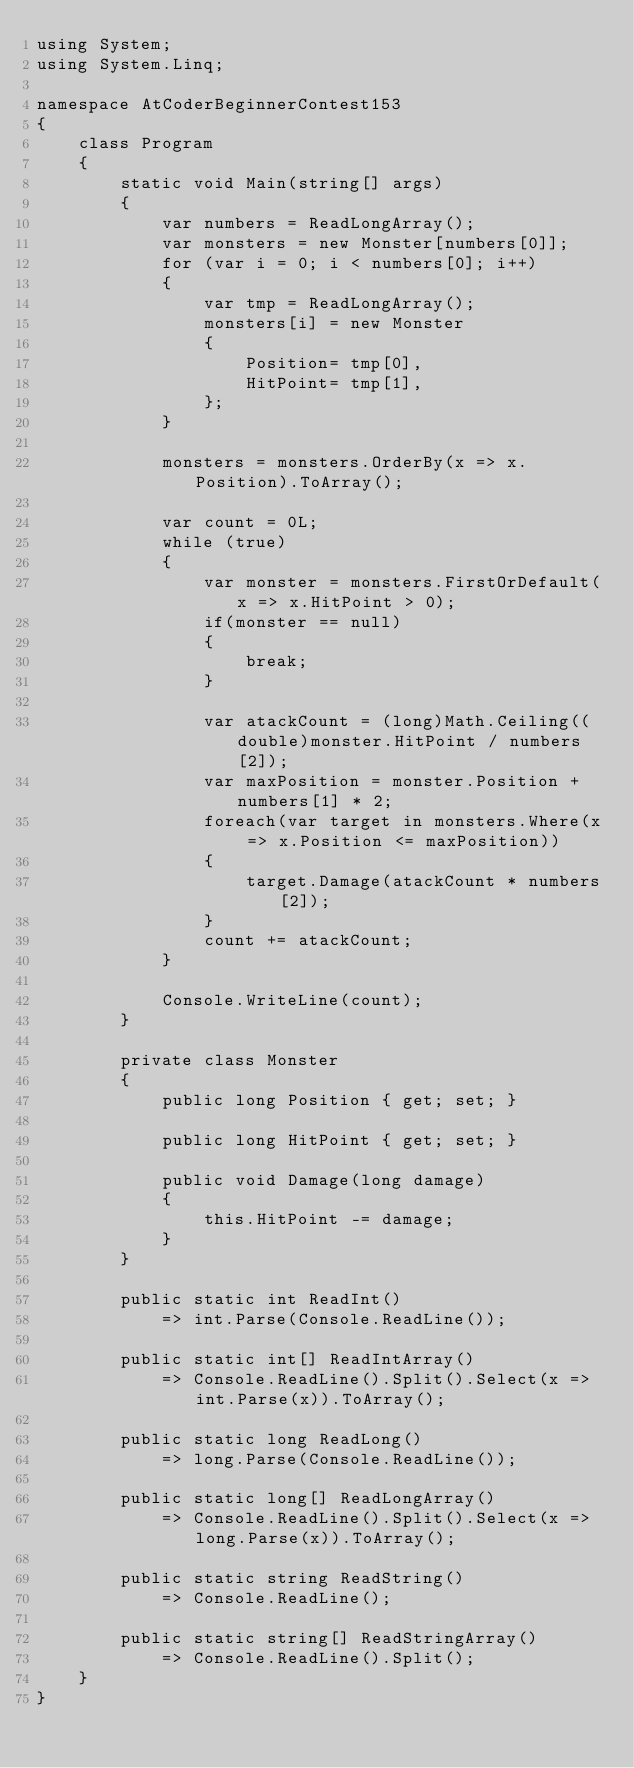Convert code to text. <code><loc_0><loc_0><loc_500><loc_500><_C#_>using System;
using System.Linq;

namespace AtCoderBeginnerContest153
{
	class Program
	{
		static void Main(string[] args)
		{
			var numbers = ReadLongArray();
			var monsters = new Monster[numbers[0]];
			for (var i = 0; i < numbers[0]; i++)
			{
				var tmp = ReadLongArray();
				monsters[i] = new Monster
				{
					Position= tmp[0],
					HitPoint= tmp[1],
				};
			}

			monsters = monsters.OrderBy(x => x.Position).ToArray();

			var count = 0L;
			while (true)
			{
				var monster = monsters.FirstOrDefault(x => x.HitPoint > 0);
				if(monster == null)
				{
					break;
				}

				var atackCount = (long)Math.Ceiling((double)monster.HitPoint / numbers[2]);
				var maxPosition = monster.Position + numbers[1] * 2;
				foreach(var target in monsters.Where(x => x.Position <= maxPosition))
				{
					target.Damage(atackCount * numbers[2]);
				}
				count += atackCount;
			}

			Console.WriteLine(count);
		}

		private class Monster
		{
			public long Position { get; set; }

			public long HitPoint { get; set; }

			public void Damage(long damage)
			{
				this.HitPoint -= damage;
			}
		}

		public static int ReadInt()
			=> int.Parse(Console.ReadLine());

		public static int[] ReadIntArray()
			=> Console.ReadLine().Split().Select(x => int.Parse(x)).ToArray();

		public static long ReadLong()
			=> long.Parse(Console.ReadLine());

		public static long[] ReadLongArray()
			=> Console.ReadLine().Split().Select(x => long.Parse(x)).ToArray();

		public static string ReadString()
			=> Console.ReadLine();

		public static string[] ReadStringArray()
			=> Console.ReadLine().Split();
	}
}
</code> 